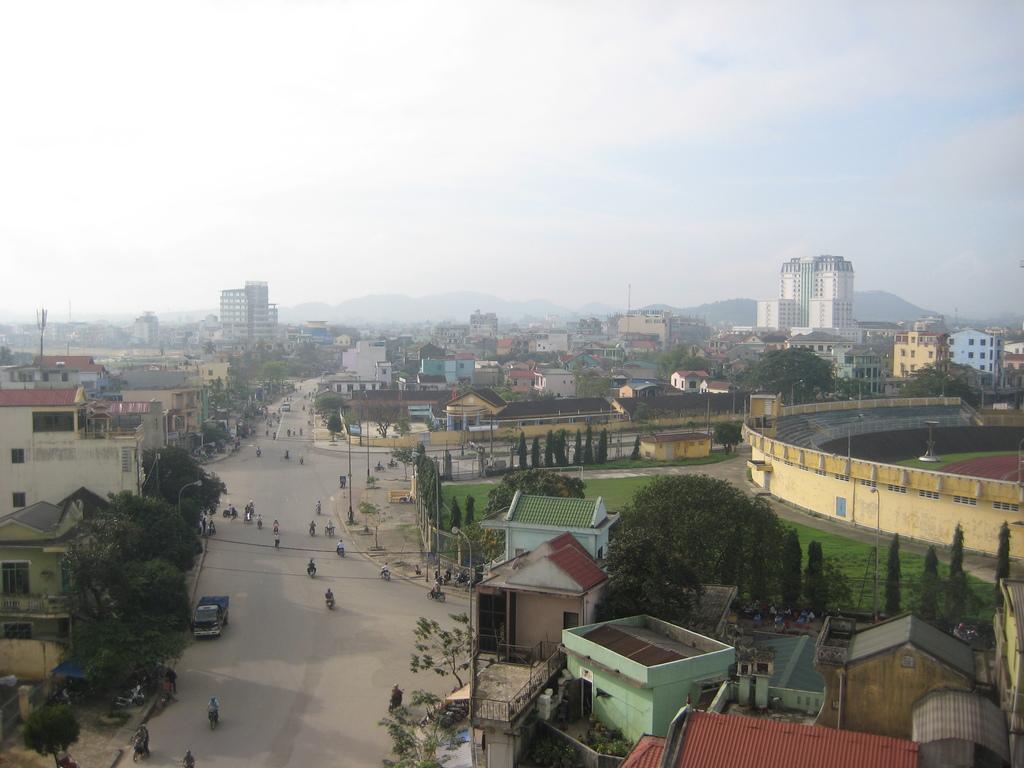Describe this image in one or two sentences. In this image, we can see the ground. There are a few vehicles, people. We can see some buildings, poles and trees. We can see a stadium on the right. We can see some hills and the sky. 